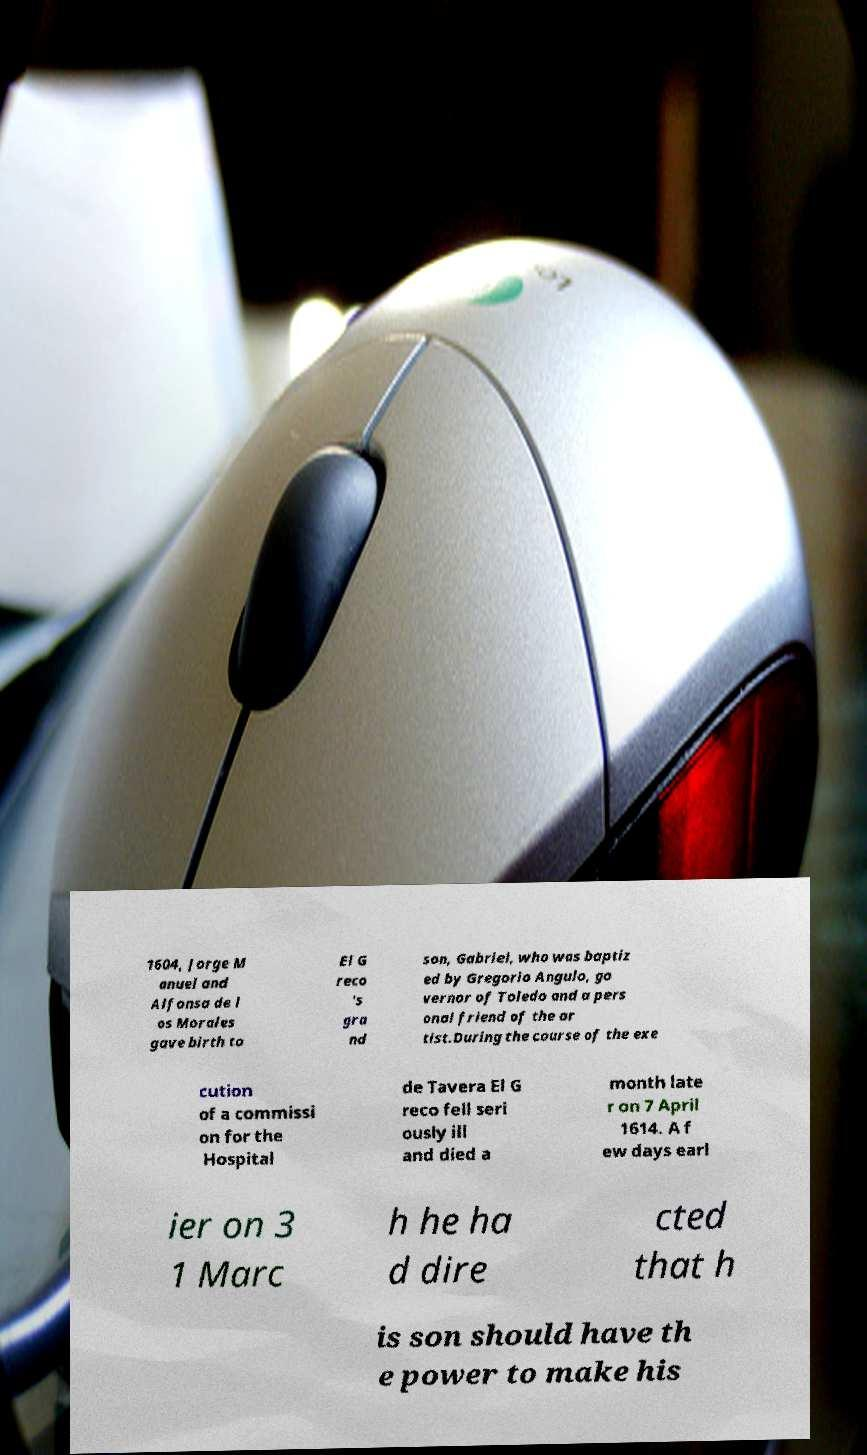There's text embedded in this image that I need extracted. Can you transcribe it verbatim? 1604, Jorge M anuel and Alfonsa de l os Morales gave birth to El G reco 's gra nd son, Gabriel, who was baptiz ed by Gregorio Angulo, go vernor of Toledo and a pers onal friend of the ar tist.During the course of the exe cution of a commissi on for the Hospital de Tavera El G reco fell seri ously ill and died a month late r on 7 April 1614. A f ew days earl ier on 3 1 Marc h he ha d dire cted that h is son should have th e power to make his 